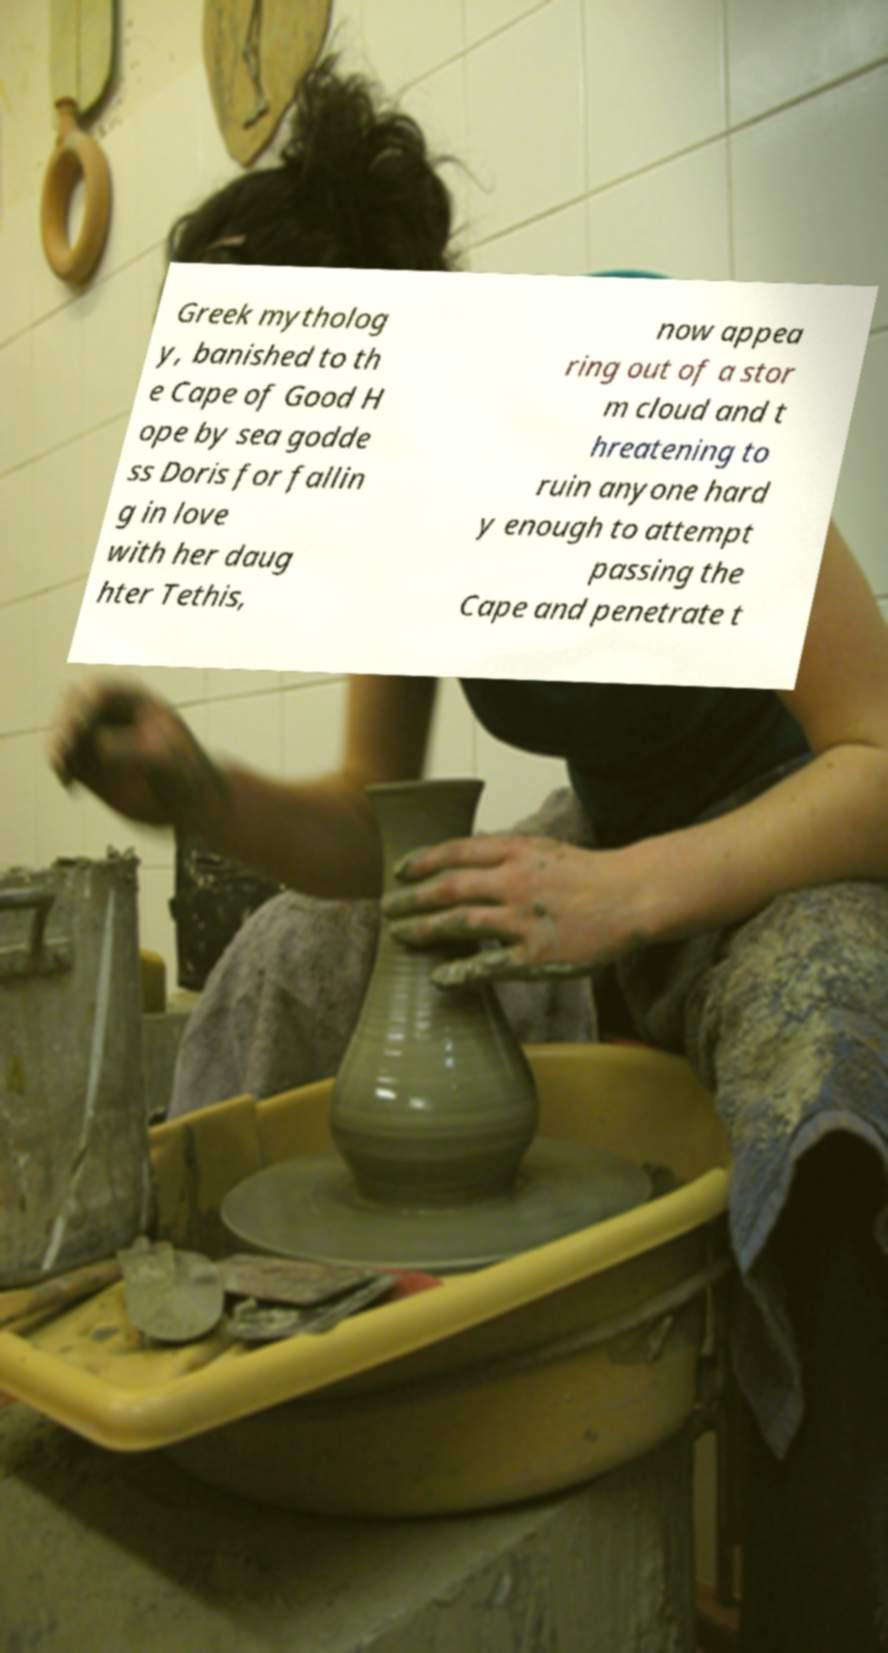I need the written content from this picture converted into text. Can you do that? Greek mytholog y, banished to th e Cape of Good H ope by sea godde ss Doris for fallin g in love with her daug hter Tethis, now appea ring out of a stor m cloud and t hreatening to ruin anyone hard y enough to attempt passing the Cape and penetrate t 